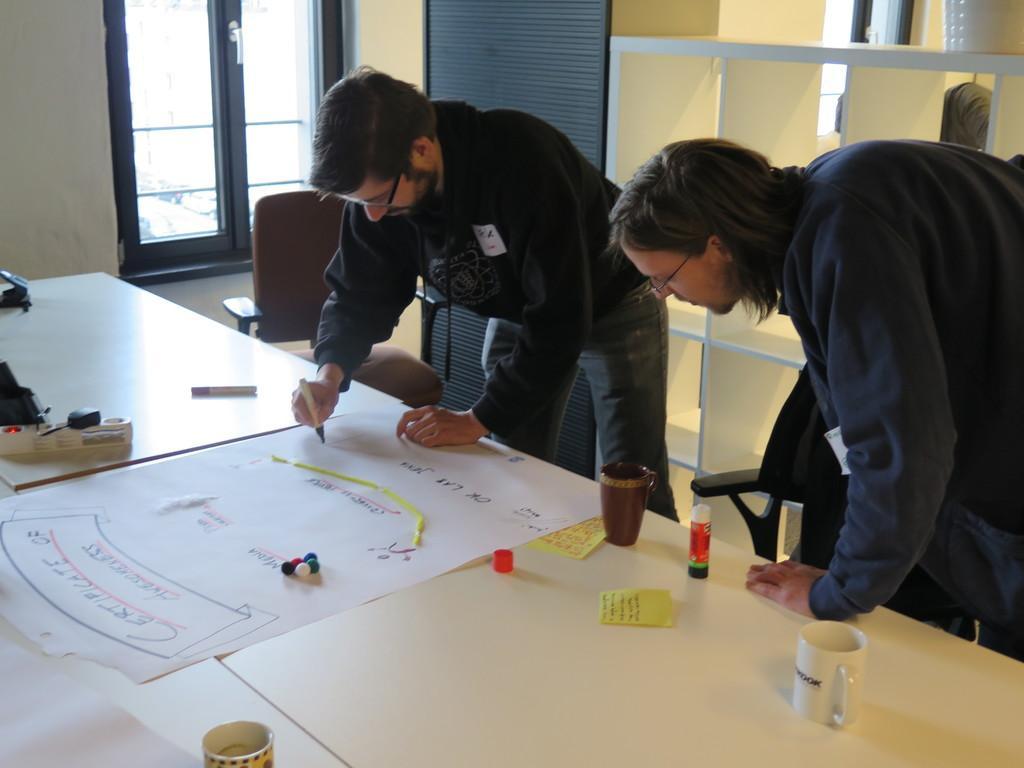How would you summarize this image in a sentence or two? This is a picture in a room, the persons are in the room, the person in black jacket were holding a pen and drawing in a paper. The paper is on the table, on the table there is a cup and glue and the stick note and background of this person is a shelf and a glass window. 